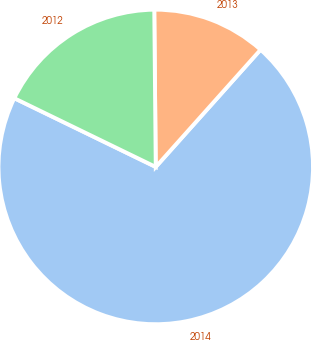Convert chart to OTSL. <chart><loc_0><loc_0><loc_500><loc_500><pie_chart><fcel>2014<fcel>2013<fcel>2012<nl><fcel>70.59%<fcel>11.76%<fcel>17.65%<nl></chart> 